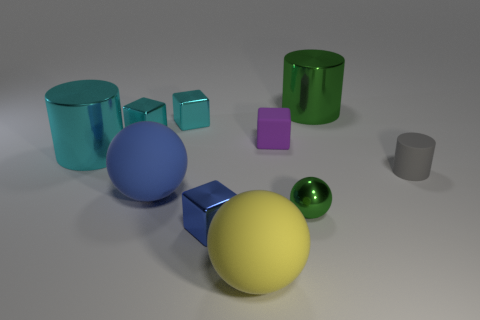Subtract 1 blocks. How many blocks are left? 3 Subtract all brown blocks. Subtract all red spheres. How many blocks are left? 4 Subtract all cubes. How many objects are left? 6 Subtract 0 red cylinders. How many objects are left? 10 Subtract all cyan metallic blocks. Subtract all small gray rubber objects. How many objects are left? 7 Add 7 gray cylinders. How many gray cylinders are left? 8 Add 3 tiny cyan shiny objects. How many tiny cyan shiny objects exist? 5 